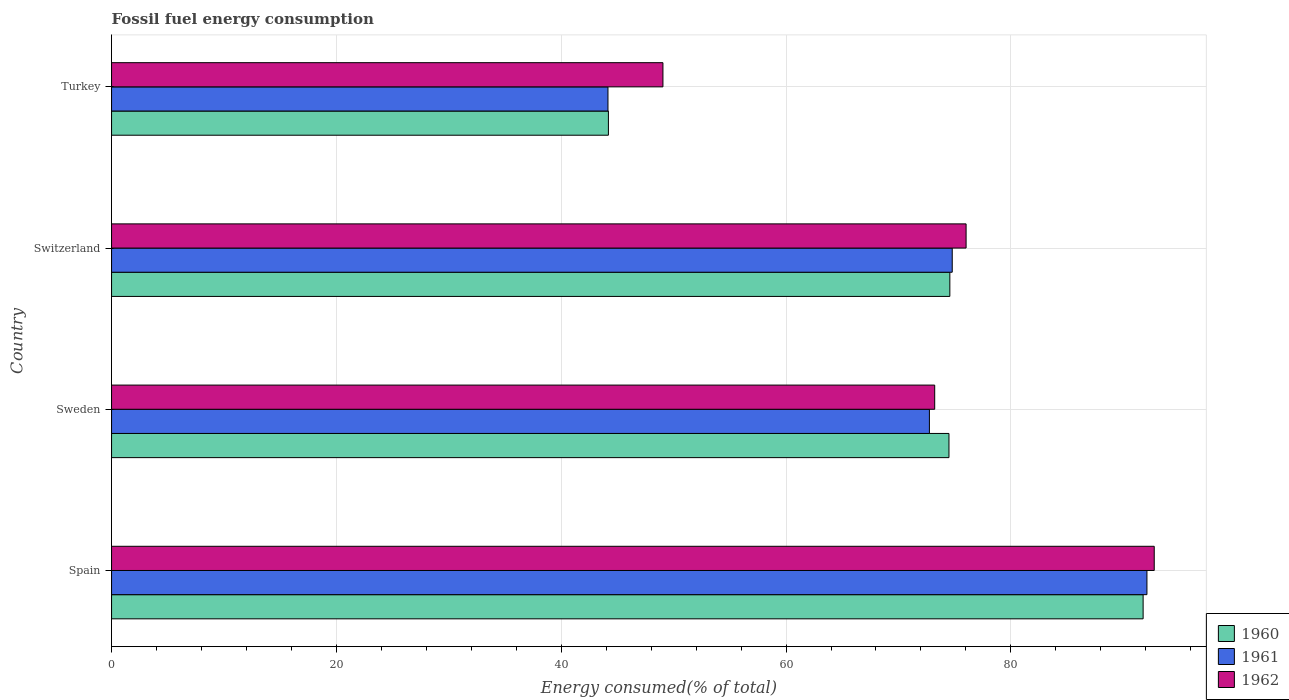How many different coloured bars are there?
Your answer should be very brief. 3. Are the number of bars per tick equal to the number of legend labels?
Make the answer very short. Yes. Are the number of bars on each tick of the Y-axis equal?
Your answer should be compact. Yes. How many bars are there on the 2nd tick from the top?
Ensure brevity in your answer.  3. What is the label of the 1st group of bars from the top?
Your response must be concise. Turkey. In how many cases, is the number of bars for a given country not equal to the number of legend labels?
Your answer should be compact. 0. What is the percentage of energy consumed in 1961 in Turkey?
Your response must be concise. 44.16. Across all countries, what is the maximum percentage of energy consumed in 1961?
Give a very brief answer. 92.1. Across all countries, what is the minimum percentage of energy consumed in 1960?
Your response must be concise. 44.2. In which country was the percentage of energy consumed in 1960 maximum?
Your answer should be very brief. Spain. What is the total percentage of energy consumed in 1961 in the graph?
Provide a succinct answer. 283.8. What is the difference between the percentage of energy consumed in 1960 in Spain and that in Switzerland?
Give a very brief answer. 17.19. What is the difference between the percentage of energy consumed in 1960 in Spain and the percentage of energy consumed in 1962 in Switzerland?
Provide a short and direct response. 15.75. What is the average percentage of energy consumed in 1960 per country?
Ensure brevity in your answer.  71.26. What is the difference between the percentage of energy consumed in 1962 and percentage of energy consumed in 1961 in Sweden?
Keep it short and to the point. 0.47. In how many countries, is the percentage of energy consumed in 1960 greater than 84 %?
Your answer should be compact. 1. What is the ratio of the percentage of energy consumed in 1961 in Spain to that in Turkey?
Offer a very short reply. 2.09. Is the percentage of energy consumed in 1962 in Sweden less than that in Turkey?
Provide a succinct answer. No. Is the difference between the percentage of energy consumed in 1962 in Sweden and Switzerland greater than the difference between the percentage of energy consumed in 1961 in Sweden and Switzerland?
Your answer should be compact. No. What is the difference between the highest and the second highest percentage of energy consumed in 1960?
Your response must be concise. 17.19. What is the difference between the highest and the lowest percentage of energy consumed in 1962?
Provide a short and direct response. 43.7. Is it the case that in every country, the sum of the percentage of energy consumed in 1960 and percentage of energy consumed in 1962 is greater than the percentage of energy consumed in 1961?
Your answer should be compact. Yes. How many bars are there?
Offer a terse response. 12. Does the graph contain grids?
Ensure brevity in your answer.  Yes. What is the title of the graph?
Make the answer very short. Fossil fuel energy consumption. Does "1977" appear as one of the legend labels in the graph?
Your answer should be compact. No. What is the label or title of the X-axis?
Provide a succinct answer. Energy consumed(% of total). What is the label or title of the Y-axis?
Keep it short and to the point. Country. What is the Energy consumed(% of total) in 1960 in Spain?
Offer a very short reply. 91.77. What is the Energy consumed(% of total) in 1961 in Spain?
Give a very brief answer. 92.1. What is the Energy consumed(% of total) of 1962 in Spain?
Your answer should be very brief. 92.75. What is the Energy consumed(% of total) in 1960 in Sweden?
Ensure brevity in your answer.  74.49. What is the Energy consumed(% of total) in 1961 in Sweden?
Provide a succinct answer. 72.75. What is the Energy consumed(% of total) in 1962 in Sweden?
Offer a very short reply. 73.23. What is the Energy consumed(% of total) of 1960 in Switzerland?
Provide a succinct answer. 74.57. What is the Energy consumed(% of total) in 1961 in Switzerland?
Keep it short and to the point. 74.78. What is the Energy consumed(% of total) in 1962 in Switzerland?
Make the answer very short. 76.02. What is the Energy consumed(% of total) of 1960 in Turkey?
Give a very brief answer. 44.2. What is the Energy consumed(% of total) in 1961 in Turkey?
Your response must be concise. 44.16. What is the Energy consumed(% of total) in 1962 in Turkey?
Keep it short and to the point. 49.05. Across all countries, what is the maximum Energy consumed(% of total) of 1960?
Offer a terse response. 91.77. Across all countries, what is the maximum Energy consumed(% of total) in 1961?
Your response must be concise. 92.1. Across all countries, what is the maximum Energy consumed(% of total) of 1962?
Make the answer very short. 92.75. Across all countries, what is the minimum Energy consumed(% of total) in 1960?
Offer a terse response. 44.2. Across all countries, what is the minimum Energy consumed(% of total) in 1961?
Offer a terse response. 44.16. Across all countries, what is the minimum Energy consumed(% of total) of 1962?
Offer a terse response. 49.05. What is the total Energy consumed(% of total) in 1960 in the graph?
Your answer should be compact. 285.03. What is the total Energy consumed(% of total) of 1961 in the graph?
Make the answer very short. 283.8. What is the total Energy consumed(% of total) of 1962 in the graph?
Provide a succinct answer. 291.05. What is the difference between the Energy consumed(% of total) of 1960 in Spain and that in Sweden?
Provide a short and direct response. 17.27. What is the difference between the Energy consumed(% of total) of 1961 in Spain and that in Sweden?
Your answer should be very brief. 19.35. What is the difference between the Energy consumed(% of total) in 1962 in Spain and that in Sweden?
Provide a short and direct response. 19.53. What is the difference between the Energy consumed(% of total) in 1960 in Spain and that in Switzerland?
Offer a terse response. 17.19. What is the difference between the Energy consumed(% of total) in 1961 in Spain and that in Switzerland?
Ensure brevity in your answer.  17.32. What is the difference between the Energy consumed(% of total) of 1962 in Spain and that in Switzerland?
Make the answer very short. 16.74. What is the difference between the Energy consumed(% of total) of 1960 in Spain and that in Turkey?
Your response must be concise. 47.57. What is the difference between the Energy consumed(% of total) of 1961 in Spain and that in Turkey?
Your answer should be compact. 47.95. What is the difference between the Energy consumed(% of total) in 1962 in Spain and that in Turkey?
Provide a short and direct response. 43.7. What is the difference between the Energy consumed(% of total) of 1960 in Sweden and that in Switzerland?
Provide a succinct answer. -0.08. What is the difference between the Energy consumed(% of total) of 1961 in Sweden and that in Switzerland?
Make the answer very short. -2.03. What is the difference between the Energy consumed(% of total) of 1962 in Sweden and that in Switzerland?
Your answer should be compact. -2.79. What is the difference between the Energy consumed(% of total) in 1960 in Sweden and that in Turkey?
Ensure brevity in your answer.  30.29. What is the difference between the Energy consumed(% of total) in 1961 in Sweden and that in Turkey?
Give a very brief answer. 28.59. What is the difference between the Energy consumed(% of total) in 1962 in Sweden and that in Turkey?
Offer a terse response. 24.18. What is the difference between the Energy consumed(% of total) in 1960 in Switzerland and that in Turkey?
Your answer should be compact. 30.37. What is the difference between the Energy consumed(% of total) in 1961 in Switzerland and that in Turkey?
Give a very brief answer. 30.62. What is the difference between the Energy consumed(% of total) in 1962 in Switzerland and that in Turkey?
Ensure brevity in your answer.  26.97. What is the difference between the Energy consumed(% of total) in 1960 in Spain and the Energy consumed(% of total) in 1961 in Sweden?
Give a very brief answer. 19.01. What is the difference between the Energy consumed(% of total) of 1960 in Spain and the Energy consumed(% of total) of 1962 in Sweden?
Provide a short and direct response. 18.54. What is the difference between the Energy consumed(% of total) of 1961 in Spain and the Energy consumed(% of total) of 1962 in Sweden?
Your answer should be very brief. 18.88. What is the difference between the Energy consumed(% of total) in 1960 in Spain and the Energy consumed(% of total) in 1961 in Switzerland?
Your response must be concise. 16.98. What is the difference between the Energy consumed(% of total) in 1960 in Spain and the Energy consumed(% of total) in 1962 in Switzerland?
Make the answer very short. 15.75. What is the difference between the Energy consumed(% of total) in 1961 in Spain and the Energy consumed(% of total) in 1962 in Switzerland?
Ensure brevity in your answer.  16.09. What is the difference between the Energy consumed(% of total) of 1960 in Spain and the Energy consumed(% of total) of 1961 in Turkey?
Ensure brevity in your answer.  47.61. What is the difference between the Energy consumed(% of total) of 1960 in Spain and the Energy consumed(% of total) of 1962 in Turkey?
Your answer should be very brief. 42.72. What is the difference between the Energy consumed(% of total) of 1961 in Spain and the Energy consumed(% of total) of 1962 in Turkey?
Make the answer very short. 43.05. What is the difference between the Energy consumed(% of total) in 1960 in Sweden and the Energy consumed(% of total) in 1961 in Switzerland?
Offer a very short reply. -0.29. What is the difference between the Energy consumed(% of total) of 1960 in Sweden and the Energy consumed(% of total) of 1962 in Switzerland?
Keep it short and to the point. -1.52. What is the difference between the Energy consumed(% of total) of 1961 in Sweden and the Energy consumed(% of total) of 1962 in Switzerland?
Give a very brief answer. -3.26. What is the difference between the Energy consumed(% of total) of 1960 in Sweden and the Energy consumed(% of total) of 1961 in Turkey?
Your answer should be compact. 30.33. What is the difference between the Energy consumed(% of total) of 1960 in Sweden and the Energy consumed(% of total) of 1962 in Turkey?
Make the answer very short. 25.44. What is the difference between the Energy consumed(% of total) in 1961 in Sweden and the Energy consumed(% of total) in 1962 in Turkey?
Provide a short and direct response. 23.7. What is the difference between the Energy consumed(% of total) in 1960 in Switzerland and the Energy consumed(% of total) in 1961 in Turkey?
Make the answer very short. 30.41. What is the difference between the Energy consumed(% of total) in 1960 in Switzerland and the Energy consumed(% of total) in 1962 in Turkey?
Your response must be concise. 25.52. What is the difference between the Energy consumed(% of total) of 1961 in Switzerland and the Energy consumed(% of total) of 1962 in Turkey?
Provide a short and direct response. 25.73. What is the average Energy consumed(% of total) of 1960 per country?
Ensure brevity in your answer.  71.26. What is the average Energy consumed(% of total) in 1961 per country?
Make the answer very short. 70.95. What is the average Energy consumed(% of total) of 1962 per country?
Ensure brevity in your answer.  72.76. What is the difference between the Energy consumed(% of total) in 1960 and Energy consumed(% of total) in 1961 in Spain?
Make the answer very short. -0.34. What is the difference between the Energy consumed(% of total) of 1960 and Energy consumed(% of total) of 1962 in Spain?
Give a very brief answer. -0.99. What is the difference between the Energy consumed(% of total) of 1961 and Energy consumed(% of total) of 1962 in Spain?
Your answer should be compact. -0.65. What is the difference between the Energy consumed(% of total) of 1960 and Energy consumed(% of total) of 1961 in Sweden?
Provide a short and direct response. 1.74. What is the difference between the Energy consumed(% of total) of 1960 and Energy consumed(% of total) of 1962 in Sweden?
Offer a terse response. 1.27. What is the difference between the Energy consumed(% of total) in 1961 and Energy consumed(% of total) in 1962 in Sweden?
Your response must be concise. -0.47. What is the difference between the Energy consumed(% of total) of 1960 and Energy consumed(% of total) of 1961 in Switzerland?
Offer a terse response. -0.21. What is the difference between the Energy consumed(% of total) of 1960 and Energy consumed(% of total) of 1962 in Switzerland?
Your answer should be compact. -1.45. What is the difference between the Energy consumed(% of total) in 1961 and Energy consumed(% of total) in 1962 in Switzerland?
Your answer should be very brief. -1.23. What is the difference between the Energy consumed(% of total) in 1960 and Energy consumed(% of total) in 1961 in Turkey?
Provide a short and direct response. 0.04. What is the difference between the Energy consumed(% of total) of 1960 and Energy consumed(% of total) of 1962 in Turkey?
Make the answer very short. -4.85. What is the difference between the Energy consumed(% of total) in 1961 and Energy consumed(% of total) in 1962 in Turkey?
Provide a succinct answer. -4.89. What is the ratio of the Energy consumed(% of total) of 1960 in Spain to that in Sweden?
Give a very brief answer. 1.23. What is the ratio of the Energy consumed(% of total) of 1961 in Spain to that in Sweden?
Your answer should be compact. 1.27. What is the ratio of the Energy consumed(% of total) in 1962 in Spain to that in Sweden?
Ensure brevity in your answer.  1.27. What is the ratio of the Energy consumed(% of total) in 1960 in Spain to that in Switzerland?
Ensure brevity in your answer.  1.23. What is the ratio of the Energy consumed(% of total) of 1961 in Spain to that in Switzerland?
Make the answer very short. 1.23. What is the ratio of the Energy consumed(% of total) in 1962 in Spain to that in Switzerland?
Give a very brief answer. 1.22. What is the ratio of the Energy consumed(% of total) of 1960 in Spain to that in Turkey?
Provide a short and direct response. 2.08. What is the ratio of the Energy consumed(% of total) of 1961 in Spain to that in Turkey?
Your answer should be very brief. 2.09. What is the ratio of the Energy consumed(% of total) of 1962 in Spain to that in Turkey?
Your answer should be very brief. 1.89. What is the ratio of the Energy consumed(% of total) of 1960 in Sweden to that in Switzerland?
Your answer should be very brief. 1. What is the ratio of the Energy consumed(% of total) in 1961 in Sweden to that in Switzerland?
Offer a very short reply. 0.97. What is the ratio of the Energy consumed(% of total) in 1962 in Sweden to that in Switzerland?
Your response must be concise. 0.96. What is the ratio of the Energy consumed(% of total) in 1960 in Sweden to that in Turkey?
Ensure brevity in your answer.  1.69. What is the ratio of the Energy consumed(% of total) of 1961 in Sweden to that in Turkey?
Keep it short and to the point. 1.65. What is the ratio of the Energy consumed(% of total) in 1962 in Sweden to that in Turkey?
Offer a terse response. 1.49. What is the ratio of the Energy consumed(% of total) of 1960 in Switzerland to that in Turkey?
Your response must be concise. 1.69. What is the ratio of the Energy consumed(% of total) of 1961 in Switzerland to that in Turkey?
Provide a succinct answer. 1.69. What is the ratio of the Energy consumed(% of total) in 1962 in Switzerland to that in Turkey?
Provide a short and direct response. 1.55. What is the difference between the highest and the second highest Energy consumed(% of total) in 1960?
Your answer should be compact. 17.19. What is the difference between the highest and the second highest Energy consumed(% of total) in 1961?
Keep it short and to the point. 17.32. What is the difference between the highest and the second highest Energy consumed(% of total) of 1962?
Your answer should be compact. 16.74. What is the difference between the highest and the lowest Energy consumed(% of total) of 1960?
Provide a short and direct response. 47.57. What is the difference between the highest and the lowest Energy consumed(% of total) of 1961?
Provide a succinct answer. 47.95. What is the difference between the highest and the lowest Energy consumed(% of total) of 1962?
Offer a terse response. 43.7. 